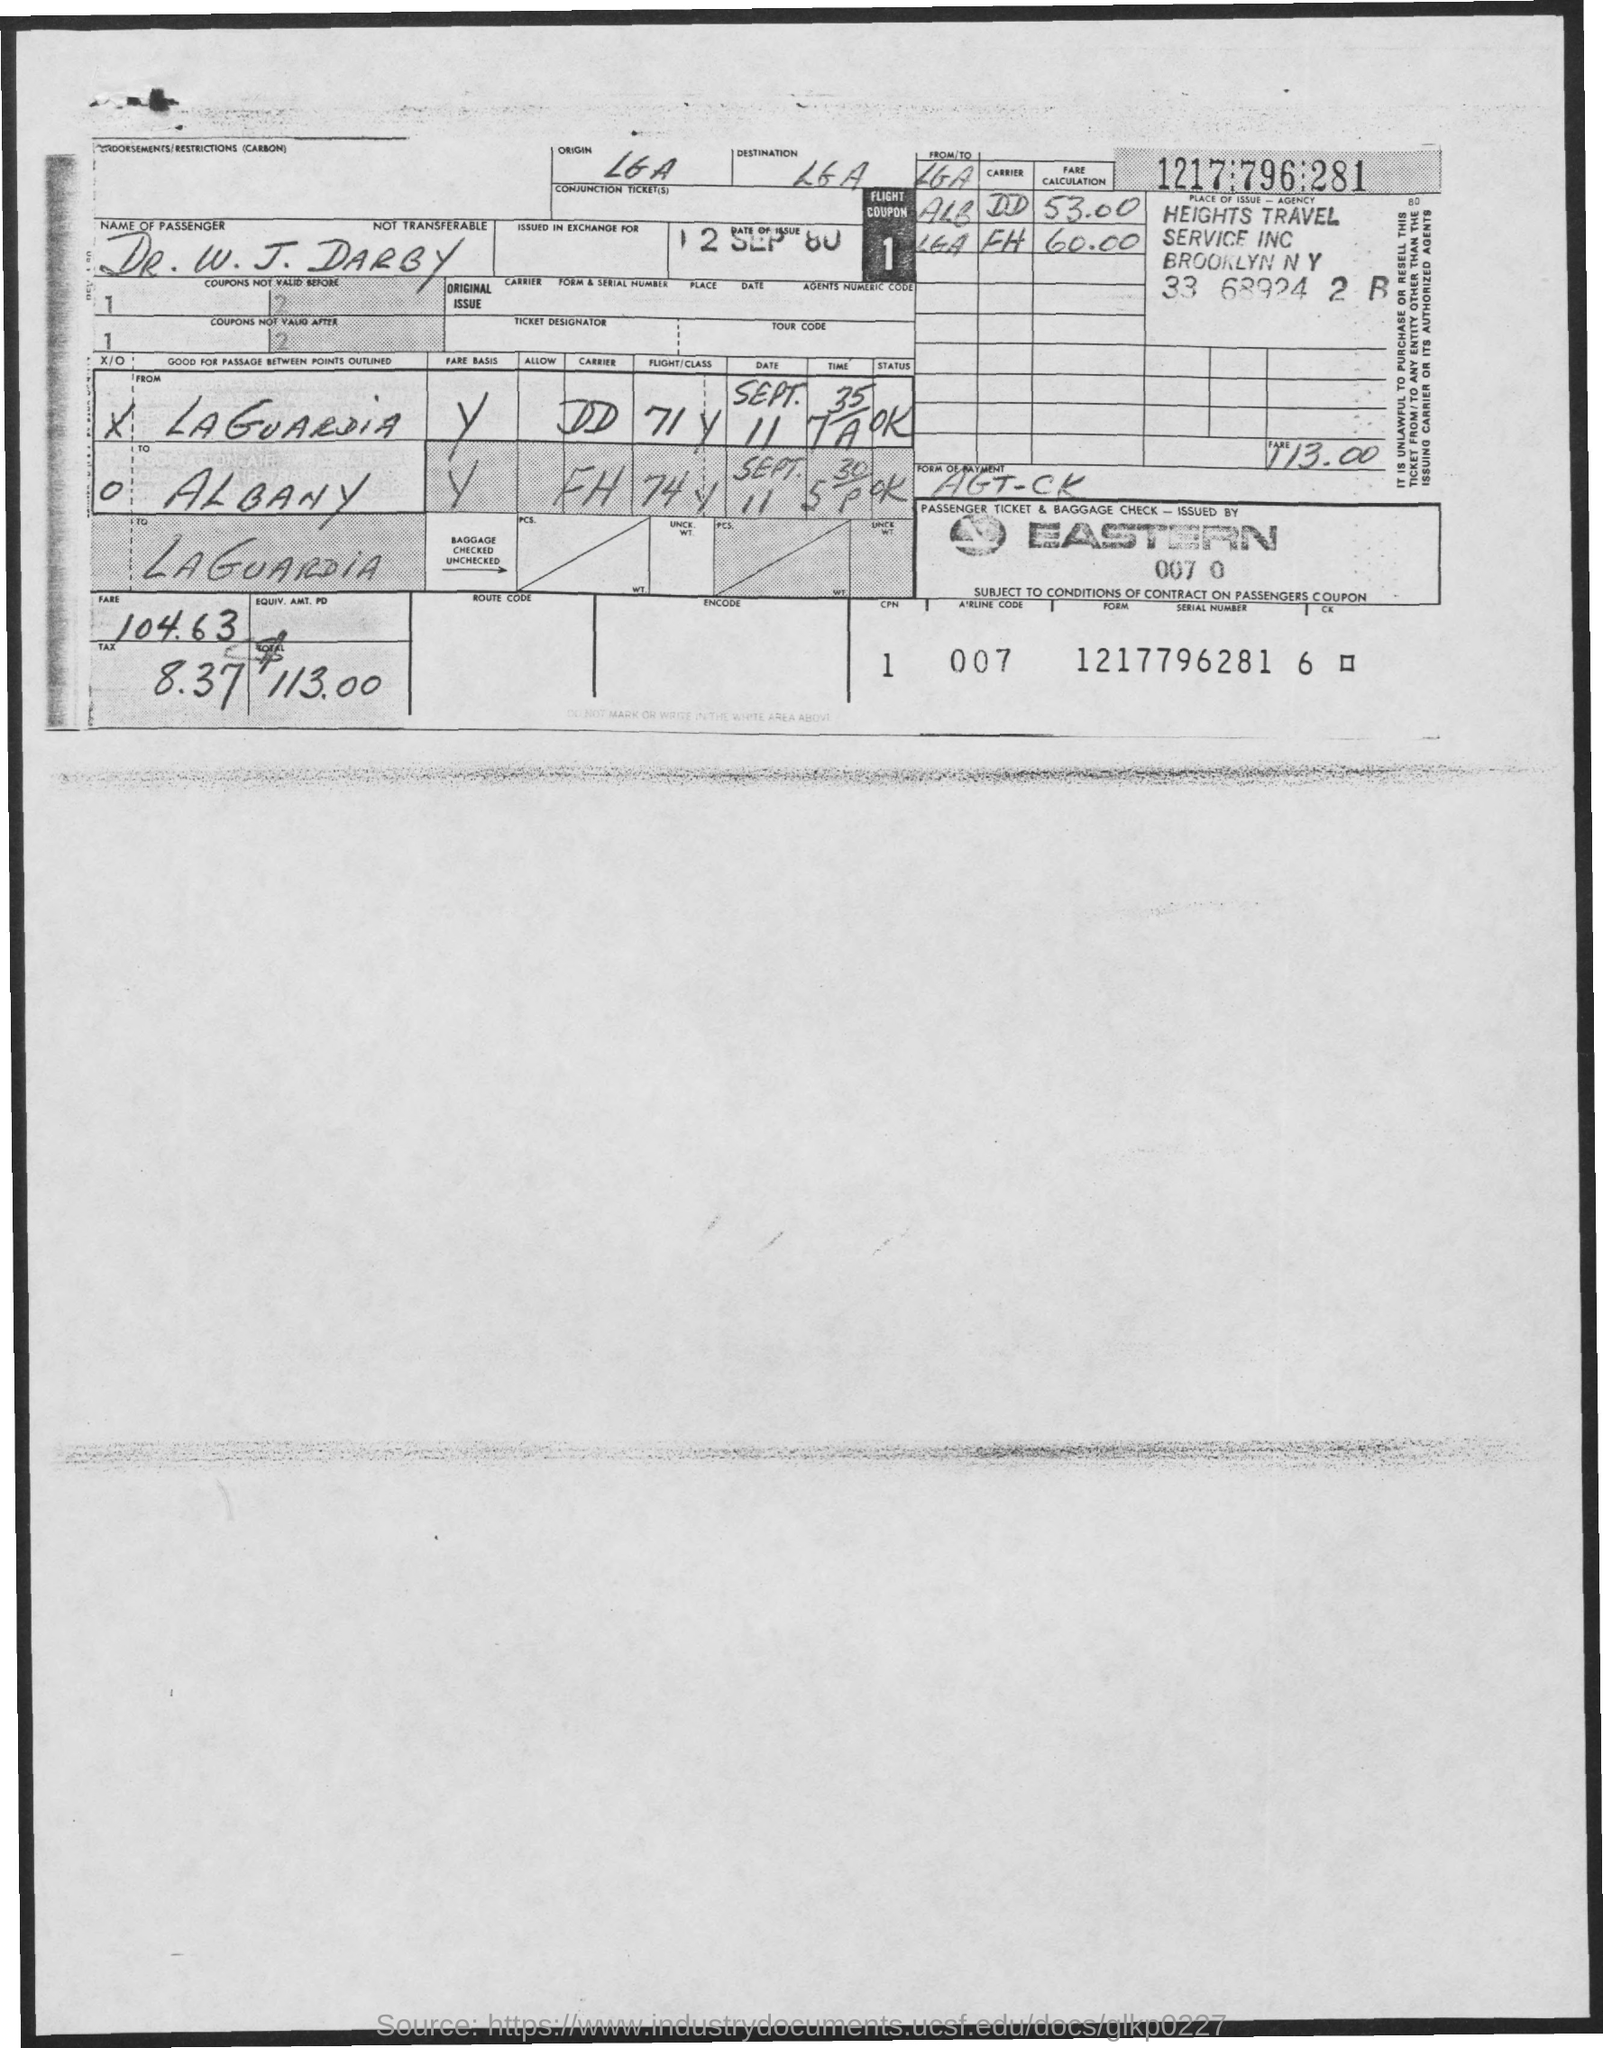Indicate a few pertinent items in this graphic. The amount of tax mentioned in the given form is 8.37. The date of issue mentioned in the given form is September 12, 1980. The amount of fare mentioned in the given form is 104.63.. The total amount mentioned in the given form is $113.00. 